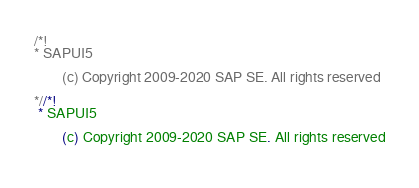<code> <loc_0><loc_0><loc_500><loc_500><_CSS_>/*!
* SAPUI5

		(c) Copyright 2009-2020 SAP SE. All rights reserved
	
*//*!
 * SAPUI5

		(c) Copyright 2009-2020 SAP SE. All rights reserved
	</code> 